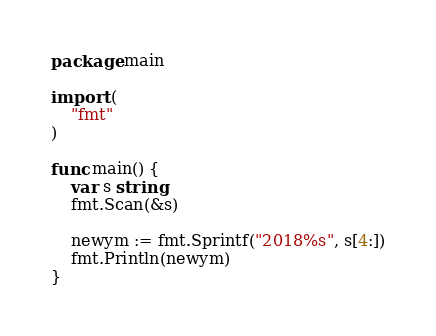Convert code to text. <code><loc_0><loc_0><loc_500><loc_500><_Go_>package main

import (
	"fmt"
)

func main() {
	var s string
	fmt.Scan(&s)

	newym := fmt.Sprintf("2018%s", s[4:])
	fmt.Println(newym)
}
</code> 